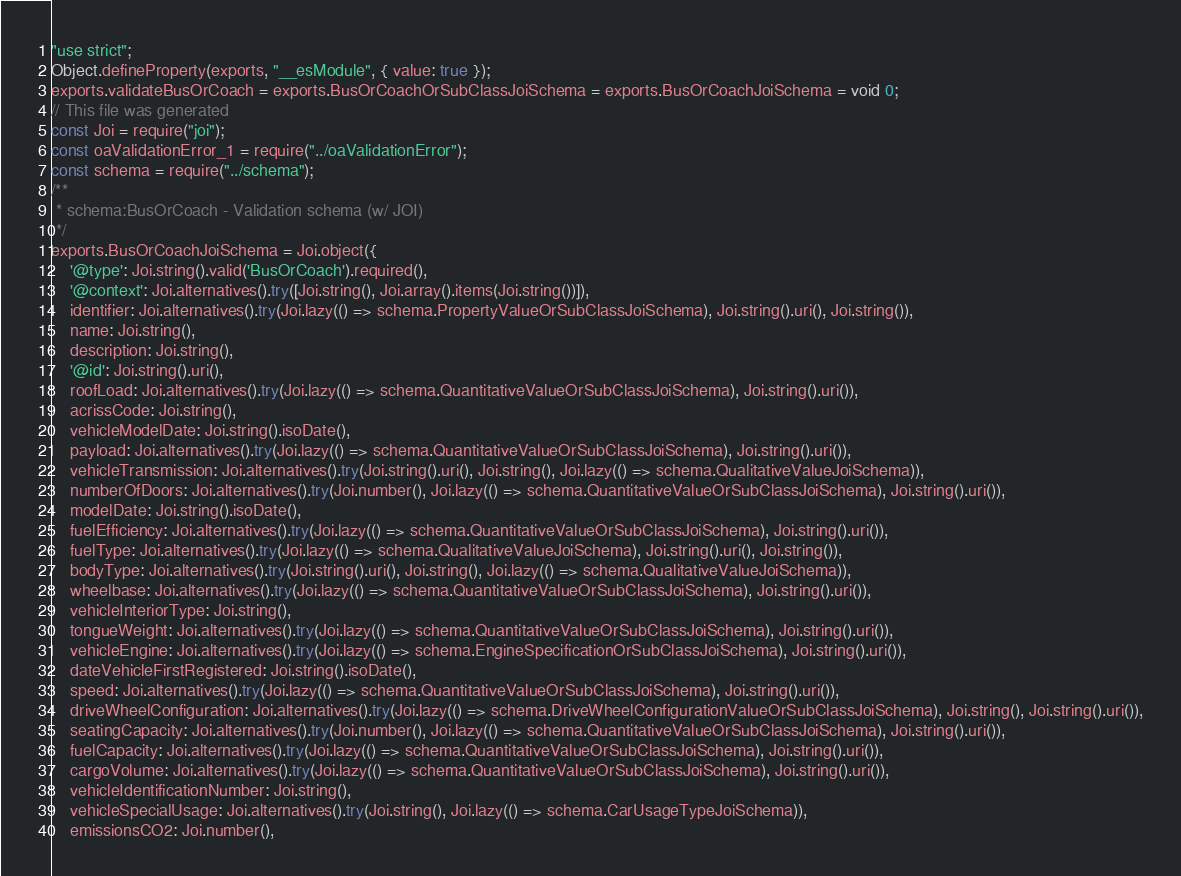Convert code to text. <code><loc_0><loc_0><loc_500><loc_500><_JavaScript_>"use strict";
Object.defineProperty(exports, "__esModule", { value: true });
exports.validateBusOrCoach = exports.BusOrCoachOrSubClassJoiSchema = exports.BusOrCoachJoiSchema = void 0;
// This file was generated
const Joi = require("joi");
const oaValidationError_1 = require("../oaValidationError");
const schema = require("../schema");
/**
 * schema:BusOrCoach - Validation schema (w/ JOI)
 */
exports.BusOrCoachJoiSchema = Joi.object({
    '@type': Joi.string().valid('BusOrCoach').required(),
    '@context': Joi.alternatives().try([Joi.string(), Joi.array().items(Joi.string())]),
    identifier: Joi.alternatives().try(Joi.lazy(() => schema.PropertyValueOrSubClassJoiSchema), Joi.string().uri(), Joi.string()),
    name: Joi.string(),
    description: Joi.string(),
    '@id': Joi.string().uri(),
    roofLoad: Joi.alternatives().try(Joi.lazy(() => schema.QuantitativeValueOrSubClassJoiSchema), Joi.string().uri()),
    acrissCode: Joi.string(),
    vehicleModelDate: Joi.string().isoDate(),
    payload: Joi.alternatives().try(Joi.lazy(() => schema.QuantitativeValueOrSubClassJoiSchema), Joi.string().uri()),
    vehicleTransmission: Joi.alternatives().try(Joi.string().uri(), Joi.string(), Joi.lazy(() => schema.QualitativeValueJoiSchema)),
    numberOfDoors: Joi.alternatives().try(Joi.number(), Joi.lazy(() => schema.QuantitativeValueOrSubClassJoiSchema), Joi.string().uri()),
    modelDate: Joi.string().isoDate(),
    fuelEfficiency: Joi.alternatives().try(Joi.lazy(() => schema.QuantitativeValueOrSubClassJoiSchema), Joi.string().uri()),
    fuelType: Joi.alternatives().try(Joi.lazy(() => schema.QualitativeValueJoiSchema), Joi.string().uri(), Joi.string()),
    bodyType: Joi.alternatives().try(Joi.string().uri(), Joi.string(), Joi.lazy(() => schema.QualitativeValueJoiSchema)),
    wheelbase: Joi.alternatives().try(Joi.lazy(() => schema.QuantitativeValueOrSubClassJoiSchema), Joi.string().uri()),
    vehicleInteriorType: Joi.string(),
    tongueWeight: Joi.alternatives().try(Joi.lazy(() => schema.QuantitativeValueOrSubClassJoiSchema), Joi.string().uri()),
    vehicleEngine: Joi.alternatives().try(Joi.lazy(() => schema.EngineSpecificationOrSubClassJoiSchema), Joi.string().uri()),
    dateVehicleFirstRegistered: Joi.string().isoDate(),
    speed: Joi.alternatives().try(Joi.lazy(() => schema.QuantitativeValueOrSubClassJoiSchema), Joi.string().uri()),
    driveWheelConfiguration: Joi.alternatives().try(Joi.lazy(() => schema.DriveWheelConfigurationValueOrSubClassJoiSchema), Joi.string(), Joi.string().uri()),
    seatingCapacity: Joi.alternatives().try(Joi.number(), Joi.lazy(() => schema.QuantitativeValueOrSubClassJoiSchema), Joi.string().uri()),
    fuelCapacity: Joi.alternatives().try(Joi.lazy(() => schema.QuantitativeValueOrSubClassJoiSchema), Joi.string().uri()),
    cargoVolume: Joi.alternatives().try(Joi.lazy(() => schema.QuantitativeValueOrSubClassJoiSchema), Joi.string().uri()),
    vehicleIdentificationNumber: Joi.string(),
    vehicleSpecialUsage: Joi.alternatives().try(Joi.string(), Joi.lazy(() => schema.CarUsageTypeJoiSchema)),
    emissionsCO2: Joi.number(),</code> 